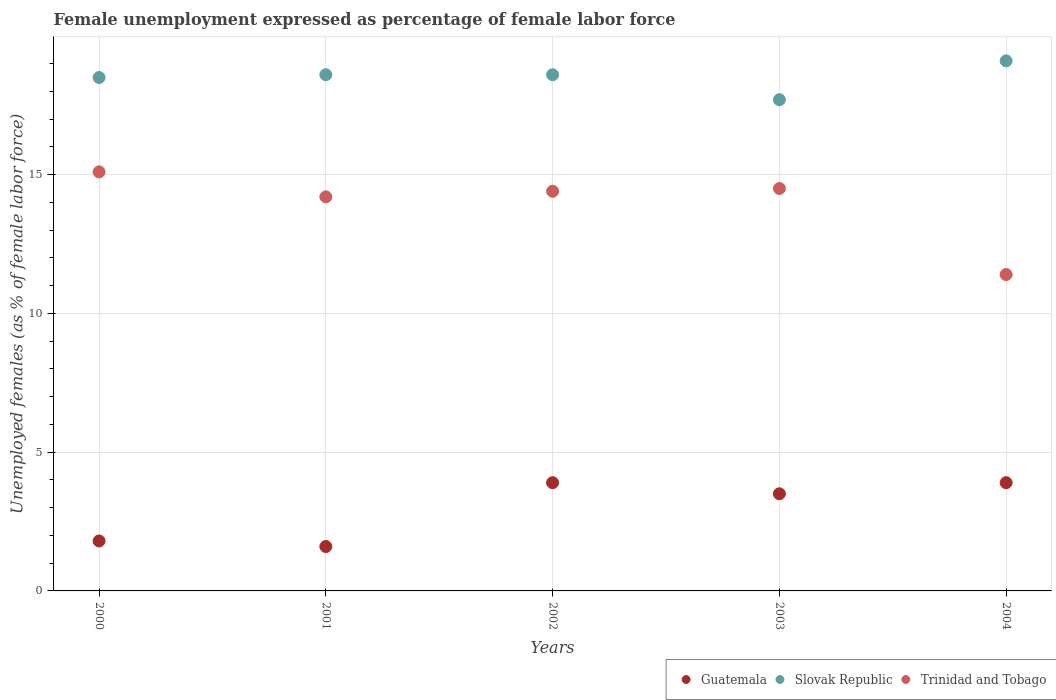Is the number of dotlines equal to the number of legend labels?
Offer a very short reply. Yes. What is the unemployment in females in in Guatemala in 2004?
Offer a terse response. 3.9. Across all years, what is the maximum unemployment in females in in Trinidad and Tobago?
Offer a very short reply. 15.1. Across all years, what is the minimum unemployment in females in in Slovak Republic?
Provide a short and direct response. 17.7. In which year was the unemployment in females in in Trinidad and Tobago maximum?
Your response must be concise. 2000. In which year was the unemployment in females in in Trinidad and Tobago minimum?
Offer a terse response. 2004. What is the total unemployment in females in in Slovak Republic in the graph?
Offer a terse response. 92.5. What is the difference between the unemployment in females in in Trinidad and Tobago in 2000 and that in 2001?
Ensure brevity in your answer.  0.9. What is the difference between the unemployment in females in in Trinidad and Tobago in 2004 and the unemployment in females in in Guatemala in 2002?
Keep it short and to the point. 7.5. What is the average unemployment in females in in Slovak Republic per year?
Give a very brief answer. 18.5. In the year 2003, what is the difference between the unemployment in females in in Trinidad and Tobago and unemployment in females in in Slovak Republic?
Offer a terse response. -3.2. What is the ratio of the unemployment in females in in Slovak Republic in 2000 to that in 2004?
Your response must be concise. 0.97. Is the difference between the unemployment in females in in Trinidad and Tobago in 2002 and 2004 greater than the difference between the unemployment in females in in Slovak Republic in 2002 and 2004?
Your answer should be compact. Yes. What is the difference between the highest and the second highest unemployment in females in in Slovak Republic?
Keep it short and to the point. 0.5. What is the difference between the highest and the lowest unemployment in females in in Slovak Republic?
Offer a terse response. 1.4. In how many years, is the unemployment in females in in Slovak Republic greater than the average unemployment in females in in Slovak Republic taken over all years?
Keep it short and to the point. 3. Is the unemployment in females in in Trinidad and Tobago strictly greater than the unemployment in females in in Guatemala over the years?
Keep it short and to the point. Yes. Is the unemployment in females in in Slovak Republic strictly less than the unemployment in females in in Trinidad and Tobago over the years?
Provide a succinct answer. No. How many dotlines are there?
Your answer should be very brief. 3. What is the difference between two consecutive major ticks on the Y-axis?
Keep it short and to the point. 5. Does the graph contain any zero values?
Keep it short and to the point. No. Does the graph contain grids?
Ensure brevity in your answer.  Yes. How many legend labels are there?
Keep it short and to the point. 3. What is the title of the graph?
Make the answer very short. Female unemployment expressed as percentage of female labor force. What is the label or title of the X-axis?
Provide a succinct answer. Years. What is the label or title of the Y-axis?
Offer a very short reply. Unemployed females (as % of female labor force). What is the Unemployed females (as % of female labor force) of Guatemala in 2000?
Your answer should be compact. 1.8. What is the Unemployed females (as % of female labor force) in Trinidad and Tobago in 2000?
Your answer should be very brief. 15.1. What is the Unemployed females (as % of female labor force) of Guatemala in 2001?
Offer a very short reply. 1.6. What is the Unemployed females (as % of female labor force) of Slovak Republic in 2001?
Your answer should be compact. 18.6. What is the Unemployed females (as % of female labor force) of Trinidad and Tobago in 2001?
Offer a very short reply. 14.2. What is the Unemployed females (as % of female labor force) of Guatemala in 2002?
Keep it short and to the point. 3.9. What is the Unemployed females (as % of female labor force) in Slovak Republic in 2002?
Keep it short and to the point. 18.6. What is the Unemployed females (as % of female labor force) in Trinidad and Tobago in 2002?
Offer a terse response. 14.4. What is the Unemployed females (as % of female labor force) in Guatemala in 2003?
Your response must be concise. 3.5. What is the Unemployed females (as % of female labor force) of Slovak Republic in 2003?
Make the answer very short. 17.7. What is the Unemployed females (as % of female labor force) in Guatemala in 2004?
Make the answer very short. 3.9. What is the Unemployed females (as % of female labor force) of Slovak Republic in 2004?
Your answer should be very brief. 19.1. What is the Unemployed females (as % of female labor force) in Trinidad and Tobago in 2004?
Your response must be concise. 11.4. Across all years, what is the maximum Unemployed females (as % of female labor force) of Guatemala?
Ensure brevity in your answer.  3.9. Across all years, what is the maximum Unemployed females (as % of female labor force) in Slovak Republic?
Offer a very short reply. 19.1. Across all years, what is the maximum Unemployed females (as % of female labor force) in Trinidad and Tobago?
Make the answer very short. 15.1. Across all years, what is the minimum Unemployed females (as % of female labor force) of Guatemala?
Your answer should be compact. 1.6. Across all years, what is the minimum Unemployed females (as % of female labor force) of Slovak Republic?
Offer a terse response. 17.7. Across all years, what is the minimum Unemployed females (as % of female labor force) in Trinidad and Tobago?
Make the answer very short. 11.4. What is the total Unemployed females (as % of female labor force) of Slovak Republic in the graph?
Your response must be concise. 92.5. What is the total Unemployed females (as % of female labor force) in Trinidad and Tobago in the graph?
Make the answer very short. 69.6. What is the difference between the Unemployed females (as % of female labor force) of Slovak Republic in 2000 and that in 2001?
Your answer should be compact. -0.1. What is the difference between the Unemployed females (as % of female labor force) of Trinidad and Tobago in 2000 and that in 2002?
Ensure brevity in your answer.  0.7. What is the difference between the Unemployed females (as % of female labor force) of Guatemala in 2000 and that in 2003?
Your answer should be very brief. -1.7. What is the difference between the Unemployed females (as % of female labor force) in Slovak Republic in 2000 and that in 2003?
Provide a short and direct response. 0.8. What is the difference between the Unemployed females (as % of female labor force) in Trinidad and Tobago in 2000 and that in 2003?
Keep it short and to the point. 0.6. What is the difference between the Unemployed females (as % of female labor force) in Guatemala in 2000 and that in 2004?
Provide a succinct answer. -2.1. What is the difference between the Unemployed females (as % of female labor force) in Slovak Republic in 2001 and that in 2002?
Make the answer very short. 0. What is the difference between the Unemployed females (as % of female labor force) of Trinidad and Tobago in 2001 and that in 2002?
Provide a short and direct response. -0.2. What is the difference between the Unemployed females (as % of female labor force) in Slovak Republic in 2001 and that in 2003?
Provide a succinct answer. 0.9. What is the difference between the Unemployed females (as % of female labor force) in Slovak Republic in 2001 and that in 2004?
Your response must be concise. -0.5. What is the difference between the Unemployed females (as % of female labor force) of Trinidad and Tobago in 2001 and that in 2004?
Keep it short and to the point. 2.8. What is the difference between the Unemployed females (as % of female labor force) in Guatemala in 2003 and that in 2004?
Your response must be concise. -0.4. What is the difference between the Unemployed females (as % of female labor force) in Trinidad and Tobago in 2003 and that in 2004?
Ensure brevity in your answer.  3.1. What is the difference between the Unemployed females (as % of female labor force) of Guatemala in 2000 and the Unemployed females (as % of female labor force) of Slovak Republic in 2001?
Give a very brief answer. -16.8. What is the difference between the Unemployed females (as % of female labor force) in Slovak Republic in 2000 and the Unemployed females (as % of female labor force) in Trinidad and Tobago in 2001?
Make the answer very short. 4.3. What is the difference between the Unemployed females (as % of female labor force) of Guatemala in 2000 and the Unemployed females (as % of female labor force) of Slovak Republic in 2002?
Make the answer very short. -16.8. What is the difference between the Unemployed females (as % of female labor force) in Guatemala in 2000 and the Unemployed females (as % of female labor force) in Trinidad and Tobago in 2002?
Your answer should be compact. -12.6. What is the difference between the Unemployed females (as % of female labor force) of Slovak Republic in 2000 and the Unemployed females (as % of female labor force) of Trinidad and Tobago in 2002?
Offer a very short reply. 4.1. What is the difference between the Unemployed females (as % of female labor force) in Guatemala in 2000 and the Unemployed females (as % of female labor force) in Slovak Republic in 2003?
Give a very brief answer. -15.9. What is the difference between the Unemployed females (as % of female labor force) in Guatemala in 2000 and the Unemployed females (as % of female labor force) in Trinidad and Tobago in 2003?
Provide a short and direct response. -12.7. What is the difference between the Unemployed females (as % of female labor force) of Guatemala in 2000 and the Unemployed females (as % of female labor force) of Slovak Republic in 2004?
Provide a short and direct response. -17.3. What is the difference between the Unemployed females (as % of female labor force) of Guatemala in 2001 and the Unemployed females (as % of female labor force) of Trinidad and Tobago in 2002?
Your answer should be compact. -12.8. What is the difference between the Unemployed females (as % of female labor force) in Slovak Republic in 2001 and the Unemployed females (as % of female labor force) in Trinidad and Tobago in 2002?
Offer a terse response. 4.2. What is the difference between the Unemployed females (as % of female labor force) in Guatemala in 2001 and the Unemployed females (as % of female labor force) in Slovak Republic in 2003?
Provide a short and direct response. -16.1. What is the difference between the Unemployed females (as % of female labor force) of Guatemala in 2001 and the Unemployed females (as % of female labor force) of Trinidad and Tobago in 2003?
Make the answer very short. -12.9. What is the difference between the Unemployed females (as % of female labor force) in Guatemala in 2001 and the Unemployed females (as % of female labor force) in Slovak Republic in 2004?
Keep it short and to the point. -17.5. What is the difference between the Unemployed females (as % of female labor force) of Guatemala in 2001 and the Unemployed females (as % of female labor force) of Trinidad and Tobago in 2004?
Your answer should be very brief. -9.8. What is the difference between the Unemployed females (as % of female labor force) of Slovak Republic in 2001 and the Unemployed females (as % of female labor force) of Trinidad and Tobago in 2004?
Your answer should be very brief. 7.2. What is the difference between the Unemployed females (as % of female labor force) in Guatemala in 2002 and the Unemployed females (as % of female labor force) in Trinidad and Tobago in 2003?
Make the answer very short. -10.6. What is the difference between the Unemployed females (as % of female labor force) of Guatemala in 2002 and the Unemployed females (as % of female labor force) of Slovak Republic in 2004?
Your response must be concise. -15.2. What is the difference between the Unemployed females (as % of female labor force) of Slovak Republic in 2002 and the Unemployed females (as % of female labor force) of Trinidad and Tobago in 2004?
Your answer should be very brief. 7.2. What is the difference between the Unemployed females (as % of female labor force) of Guatemala in 2003 and the Unemployed females (as % of female labor force) of Slovak Republic in 2004?
Keep it short and to the point. -15.6. What is the difference between the Unemployed females (as % of female labor force) in Guatemala in 2003 and the Unemployed females (as % of female labor force) in Trinidad and Tobago in 2004?
Your response must be concise. -7.9. What is the average Unemployed females (as % of female labor force) in Guatemala per year?
Offer a very short reply. 2.94. What is the average Unemployed females (as % of female labor force) of Slovak Republic per year?
Keep it short and to the point. 18.5. What is the average Unemployed females (as % of female labor force) of Trinidad and Tobago per year?
Keep it short and to the point. 13.92. In the year 2000, what is the difference between the Unemployed females (as % of female labor force) of Guatemala and Unemployed females (as % of female labor force) of Slovak Republic?
Provide a short and direct response. -16.7. In the year 2000, what is the difference between the Unemployed females (as % of female labor force) in Guatemala and Unemployed females (as % of female labor force) in Trinidad and Tobago?
Provide a succinct answer. -13.3. In the year 2001, what is the difference between the Unemployed females (as % of female labor force) in Guatemala and Unemployed females (as % of female labor force) in Trinidad and Tobago?
Offer a terse response. -12.6. In the year 2001, what is the difference between the Unemployed females (as % of female labor force) in Slovak Republic and Unemployed females (as % of female labor force) in Trinidad and Tobago?
Your answer should be compact. 4.4. In the year 2002, what is the difference between the Unemployed females (as % of female labor force) in Guatemala and Unemployed females (as % of female labor force) in Slovak Republic?
Make the answer very short. -14.7. In the year 2002, what is the difference between the Unemployed females (as % of female labor force) in Guatemala and Unemployed females (as % of female labor force) in Trinidad and Tobago?
Provide a short and direct response. -10.5. In the year 2002, what is the difference between the Unemployed females (as % of female labor force) in Slovak Republic and Unemployed females (as % of female labor force) in Trinidad and Tobago?
Offer a terse response. 4.2. In the year 2003, what is the difference between the Unemployed females (as % of female labor force) in Guatemala and Unemployed females (as % of female labor force) in Trinidad and Tobago?
Give a very brief answer. -11. In the year 2003, what is the difference between the Unemployed females (as % of female labor force) in Slovak Republic and Unemployed females (as % of female labor force) in Trinidad and Tobago?
Offer a very short reply. 3.2. In the year 2004, what is the difference between the Unemployed females (as % of female labor force) in Guatemala and Unemployed females (as % of female labor force) in Slovak Republic?
Make the answer very short. -15.2. In the year 2004, what is the difference between the Unemployed females (as % of female labor force) of Guatemala and Unemployed females (as % of female labor force) of Trinidad and Tobago?
Provide a succinct answer. -7.5. In the year 2004, what is the difference between the Unemployed females (as % of female labor force) of Slovak Republic and Unemployed females (as % of female labor force) of Trinidad and Tobago?
Keep it short and to the point. 7.7. What is the ratio of the Unemployed females (as % of female labor force) in Guatemala in 2000 to that in 2001?
Provide a short and direct response. 1.12. What is the ratio of the Unemployed females (as % of female labor force) in Slovak Republic in 2000 to that in 2001?
Provide a succinct answer. 0.99. What is the ratio of the Unemployed females (as % of female labor force) in Trinidad and Tobago in 2000 to that in 2001?
Keep it short and to the point. 1.06. What is the ratio of the Unemployed females (as % of female labor force) in Guatemala in 2000 to that in 2002?
Your response must be concise. 0.46. What is the ratio of the Unemployed females (as % of female labor force) of Slovak Republic in 2000 to that in 2002?
Ensure brevity in your answer.  0.99. What is the ratio of the Unemployed females (as % of female labor force) of Trinidad and Tobago in 2000 to that in 2002?
Your answer should be very brief. 1.05. What is the ratio of the Unemployed females (as % of female labor force) of Guatemala in 2000 to that in 2003?
Provide a short and direct response. 0.51. What is the ratio of the Unemployed females (as % of female labor force) in Slovak Republic in 2000 to that in 2003?
Keep it short and to the point. 1.05. What is the ratio of the Unemployed females (as % of female labor force) of Trinidad and Tobago in 2000 to that in 2003?
Your answer should be compact. 1.04. What is the ratio of the Unemployed females (as % of female labor force) in Guatemala in 2000 to that in 2004?
Give a very brief answer. 0.46. What is the ratio of the Unemployed females (as % of female labor force) in Slovak Republic in 2000 to that in 2004?
Give a very brief answer. 0.97. What is the ratio of the Unemployed females (as % of female labor force) of Trinidad and Tobago in 2000 to that in 2004?
Make the answer very short. 1.32. What is the ratio of the Unemployed females (as % of female labor force) of Guatemala in 2001 to that in 2002?
Ensure brevity in your answer.  0.41. What is the ratio of the Unemployed females (as % of female labor force) of Slovak Republic in 2001 to that in 2002?
Provide a succinct answer. 1. What is the ratio of the Unemployed females (as % of female labor force) of Trinidad and Tobago in 2001 to that in 2002?
Ensure brevity in your answer.  0.99. What is the ratio of the Unemployed females (as % of female labor force) in Guatemala in 2001 to that in 2003?
Your response must be concise. 0.46. What is the ratio of the Unemployed females (as % of female labor force) in Slovak Republic in 2001 to that in 2003?
Your response must be concise. 1.05. What is the ratio of the Unemployed females (as % of female labor force) in Trinidad and Tobago in 2001 to that in 2003?
Give a very brief answer. 0.98. What is the ratio of the Unemployed females (as % of female labor force) of Guatemala in 2001 to that in 2004?
Give a very brief answer. 0.41. What is the ratio of the Unemployed females (as % of female labor force) in Slovak Republic in 2001 to that in 2004?
Make the answer very short. 0.97. What is the ratio of the Unemployed females (as % of female labor force) of Trinidad and Tobago in 2001 to that in 2004?
Provide a succinct answer. 1.25. What is the ratio of the Unemployed females (as % of female labor force) in Guatemala in 2002 to that in 2003?
Provide a short and direct response. 1.11. What is the ratio of the Unemployed females (as % of female labor force) in Slovak Republic in 2002 to that in 2003?
Give a very brief answer. 1.05. What is the ratio of the Unemployed females (as % of female labor force) of Trinidad and Tobago in 2002 to that in 2003?
Keep it short and to the point. 0.99. What is the ratio of the Unemployed females (as % of female labor force) of Slovak Republic in 2002 to that in 2004?
Your answer should be very brief. 0.97. What is the ratio of the Unemployed females (as % of female labor force) of Trinidad and Tobago in 2002 to that in 2004?
Make the answer very short. 1.26. What is the ratio of the Unemployed females (as % of female labor force) of Guatemala in 2003 to that in 2004?
Your answer should be very brief. 0.9. What is the ratio of the Unemployed females (as % of female labor force) in Slovak Republic in 2003 to that in 2004?
Make the answer very short. 0.93. What is the ratio of the Unemployed females (as % of female labor force) in Trinidad and Tobago in 2003 to that in 2004?
Your response must be concise. 1.27. What is the difference between the highest and the second highest Unemployed females (as % of female labor force) in Slovak Republic?
Ensure brevity in your answer.  0.5. What is the difference between the highest and the second highest Unemployed females (as % of female labor force) in Trinidad and Tobago?
Keep it short and to the point. 0.6. What is the difference between the highest and the lowest Unemployed females (as % of female labor force) in Slovak Republic?
Offer a terse response. 1.4. 